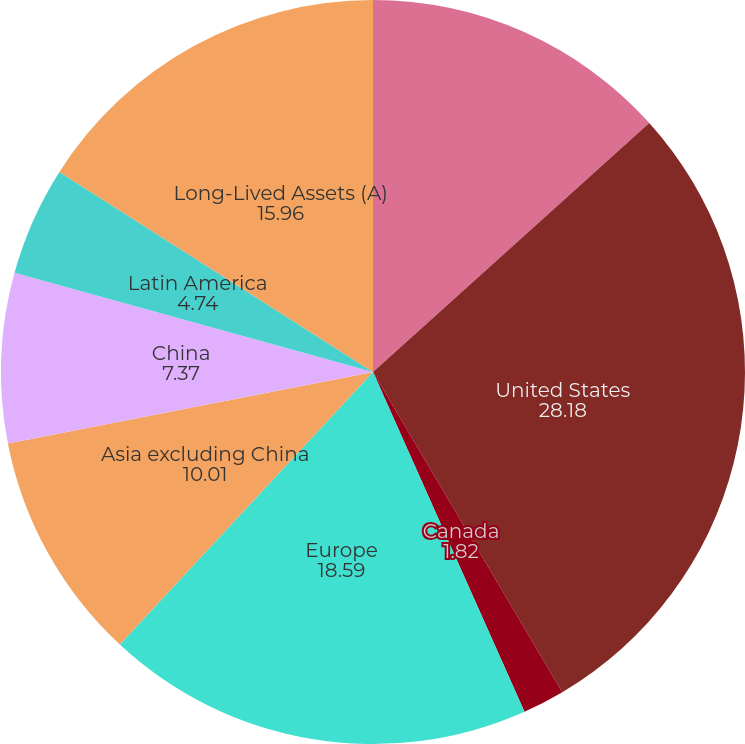<chart> <loc_0><loc_0><loc_500><loc_500><pie_chart><fcel>Sales to External Customers<fcel>United States<fcel>Canada<fcel>Europe<fcel>Asia excluding China<fcel>China<fcel>Latin America<fcel>Long-Lived Assets (A)<nl><fcel>13.32%<fcel>28.18%<fcel>1.82%<fcel>18.59%<fcel>10.01%<fcel>7.37%<fcel>4.74%<fcel>15.96%<nl></chart> 